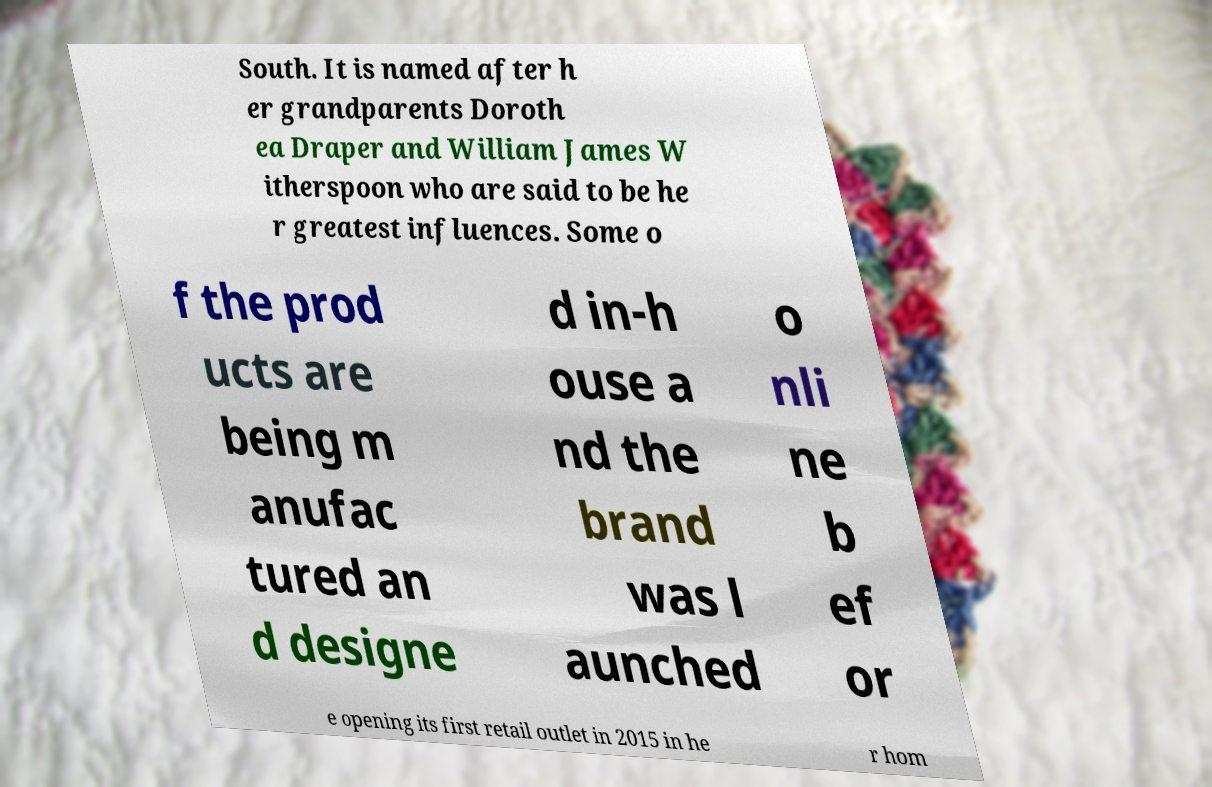Could you assist in decoding the text presented in this image and type it out clearly? South. It is named after h er grandparents Doroth ea Draper and William James W itherspoon who are said to be he r greatest influences. Some o f the prod ucts are being m anufac tured an d designe d in-h ouse a nd the brand was l aunched o nli ne b ef or e opening its first retail outlet in 2015 in he r hom 